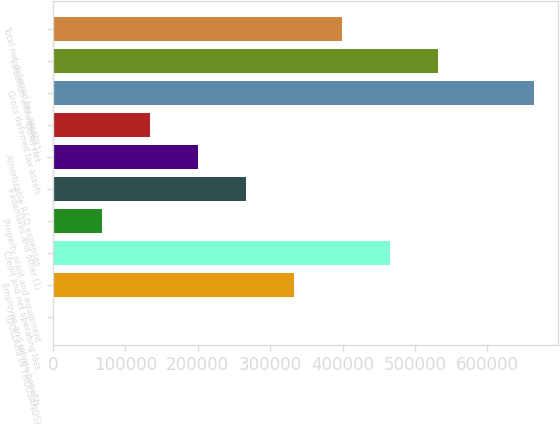Convert chart to OTSL. <chart><loc_0><loc_0><loc_500><loc_500><bar_chart><fcel>(DOLLARS IN THOUSANDS)<fcel>Employee and retiree benefits<fcel>Credit and net operating loss<fcel>Property plant and equipment<fcel>Trademarks and other (1)<fcel>Amortizable R&D expenses<fcel>Other net<fcel>Gross deferred tax assets<fcel>Valuation allowance (1)<fcel>Total net deferred tax assets<nl><fcel>2012<fcel>333470<fcel>466053<fcel>68303.6<fcel>267178<fcel>200887<fcel>134595<fcel>664928<fcel>532345<fcel>399762<nl></chart> 